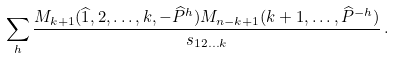Convert formula to latex. <formula><loc_0><loc_0><loc_500><loc_500>\sum _ { h } \frac { M _ { k + 1 } ( \widehat { 1 } , 2 , \dots , k , - \widehat { P } ^ { h } ) M _ { n - k + 1 } ( k + 1 , \dots , \widehat { P } ^ { - h } ) } { s _ { 1 2 \dots k } } \, .</formula> 